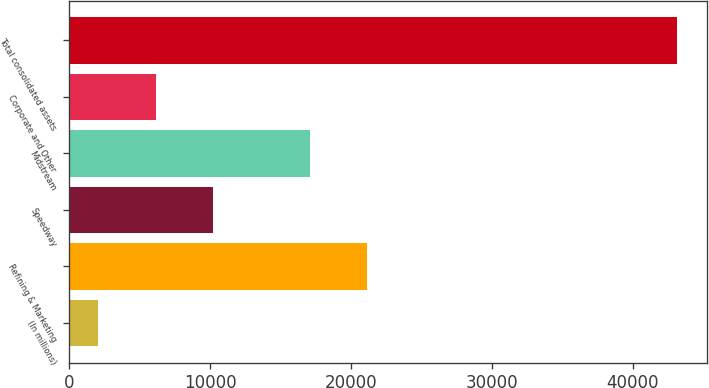<chart> <loc_0><loc_0><loc_500><loc_500><bar_chart><fcel>(In millions)<fcel>Refining & Marketing<fcel>Speedway<fcel>Midstream<fcel>Corporate and Other<fcel>Total consolidated assets<nl><fcel>2015<fcel>21171<fcel>10235<fcel>17061<fcel>6125<fcel>43115<nl></chart> 